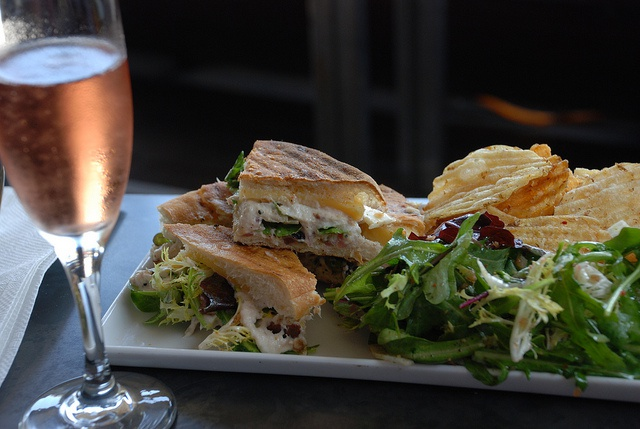Describe the objects in this image and their specific colors. I can see wine glass in gray, maroon, black, and brown tones, dining table in gray, black, and lightblue tones, sandwich in gray, olive, and black tones, and sandwich in gray, olive, and darkgray tones in this image. 